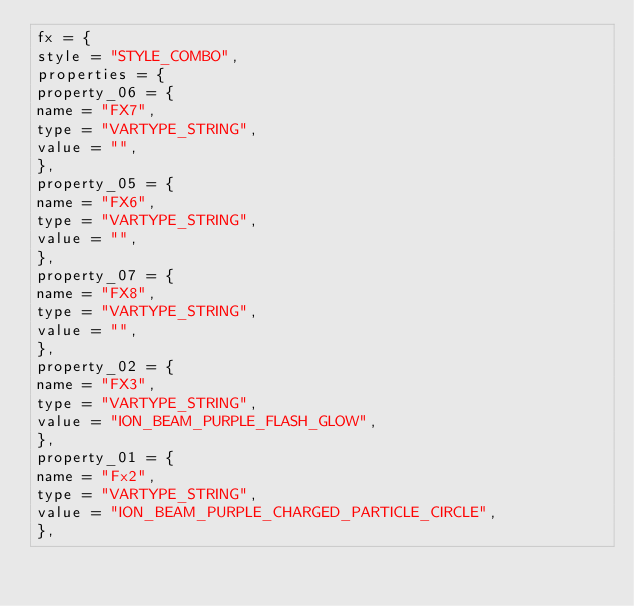<code> <loc_0><loc_0><loc_500><loc_500><_Lua_>fx = {
style = "STYLE_COMBO",
properties = {
property_06 = {
name = "FX7",
type = "VARTYPE_STRING",
value = "",
},
property_05 = {
name = "FX6",
type = "VARTYPE_STRING",
value = "",
},
property_07 = {
name = "FX8",
type = "VARTYPE_STRING",
value = "",
},
property_02 = {
name = "FX3",
type = "VARTYPE_STRING",
value = "ION_BEAM_PURPLE_FLASH_GLOW",
},
property_01 = {
name = "Fx2",
type = "VARTYPE_STRING",
value = "ION_BEAM_PURPLE_CHARGED_PARTICLE_CIRCLE",
},</code> 